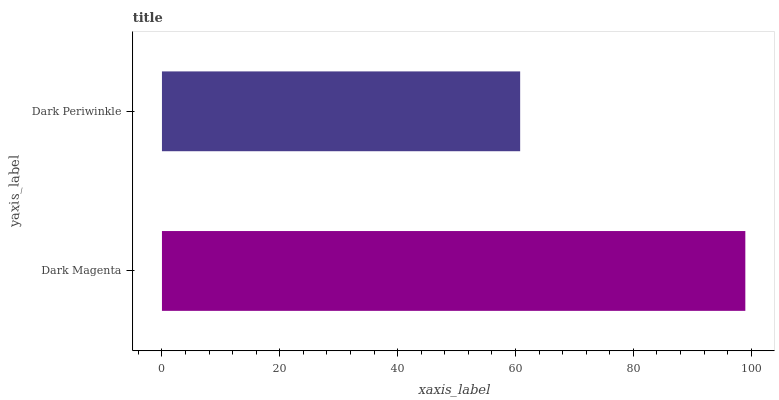Is Dark Periwinkle the minimum?
Answer yes or no. Yes. Is Dark Magenta the maximum?
Answer yes or no. Yes. Is Dark Periwinkle the maximum?
Answer yes or no. No. Is Dark Magenta greater than Dark Periwinkle?
Answer yes or no. Yes. Is Dark Periwinkle less than Dark Magenta?
Answer yes or no. Yes. Is Dark Periwinkle greater than Dark Magenta?
Answer yes or no. No. Is Dark Magenta less than Dark Periwinkle?
Answer yes or no. No. Is Dark Magenta the high median?
Answer yes or no. Yes. Is Dark Periwinkle the low median?
Answer yes or no. Yes. Is Dark Periwinkle the high median?
Answer yes or no. No. Is Dark Magenta the low median?
Answer yes or no. No. 